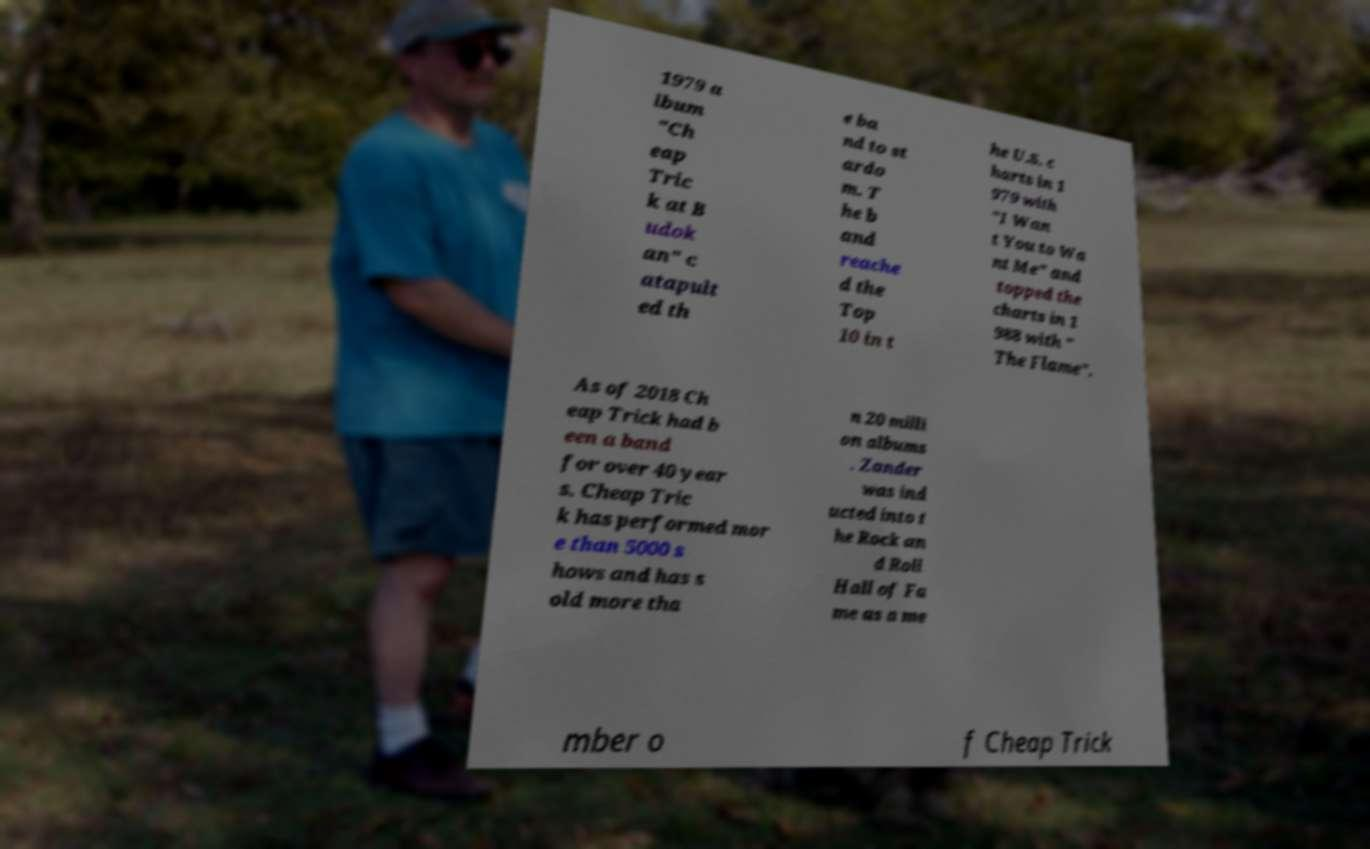There's text embedded in this image that I need extracted. Can you transcribe it verbatim? 1979 a lbum "Ch eap Tric k at B udok an" c atapult ed th e ba nd to st ardo m. T he b and reache d the Top 10 in t he U.S. c harts in 1 979 with "I Wan t You to Wa nt Me" and topped the charts in 1 988 with " The Flame". As of 2018 Ch eap Trick had b een a band for over 40 year s. Cheap Tric k has performed mor e than 5000 s hows and has s old more tha n 20 milli on albums . Zander was ind ucted into t he Rock an d Roll Hall of Fa me as a me mber o f Cheap Trick 